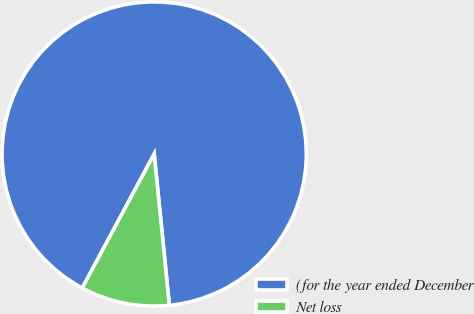<chart> <loc_0><loc_0><loc_500><loc_500><pie_chart><fcel>(for the year ended December<fcel>Net loss<nl><fcel>90.57%<fcel>9.43%<nl></chart> 